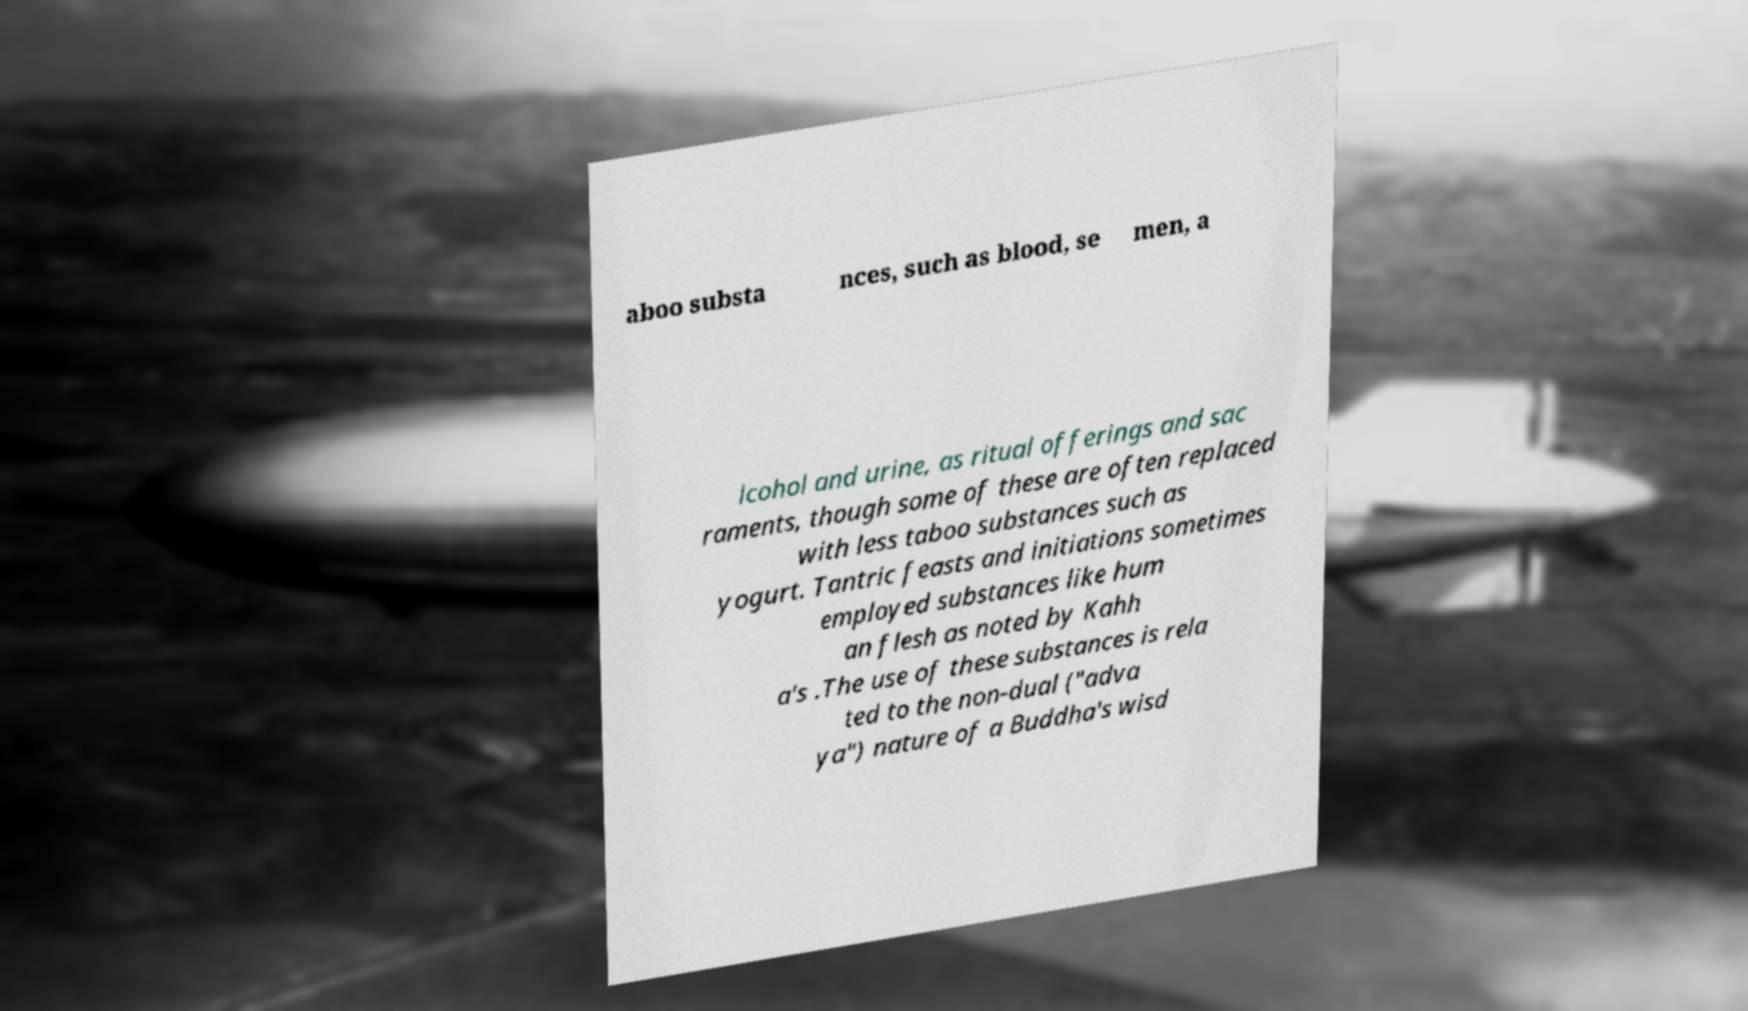Can you accurately transcribe the text from the provided image for me? aboo substa nces, such as blood, se men, a lcohol and urine, as ritual offerings and sac raments, though some of these are often replaced with less taboo substances such as yogurt. Tantric feasts and initiations sometimes employed substances like hum an flesh as noted by Kahh a's .The use of these substances is rela ted to the non-dual ("adva ya") nature of a Buddha's wisd 